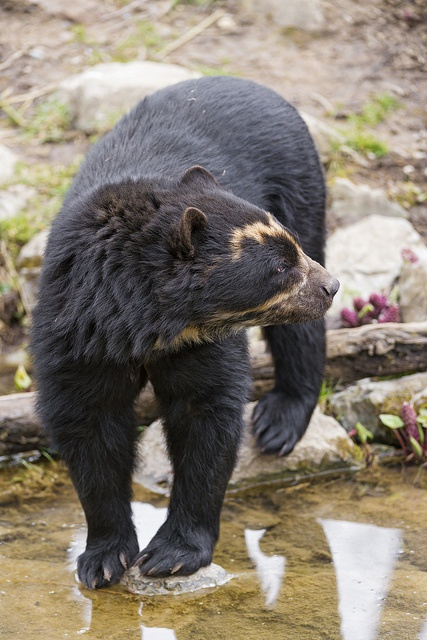Describe the objects in this image and their specific colors. I can see a bear in gray, black, and darkgray tones in this image. 